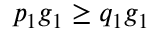Convert formula to latex. <formula><loc_0><loc_0><loc_500><loc_500>p _ { 1 } g _ { 1 } \geq q _ { 1 } g _ { 1 }</formula> 